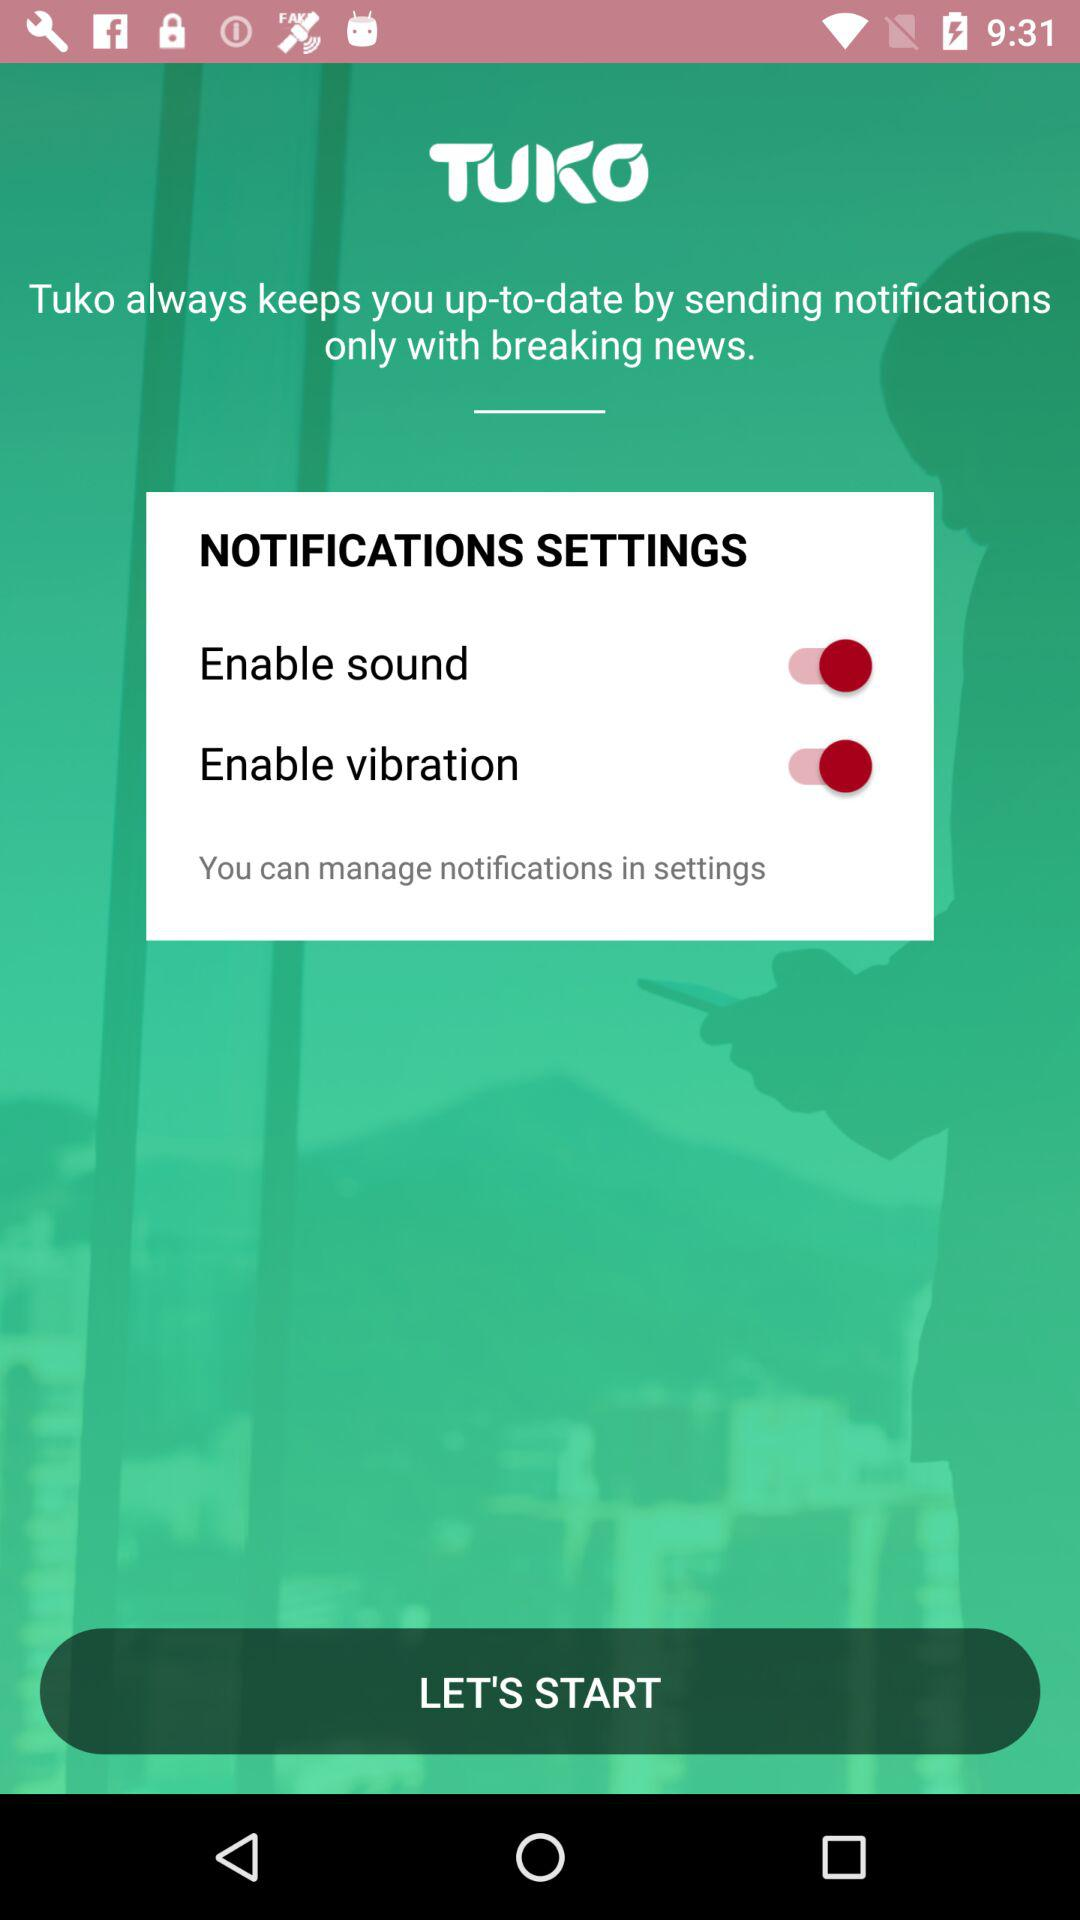What is the application name? The application name is "TUKO". 